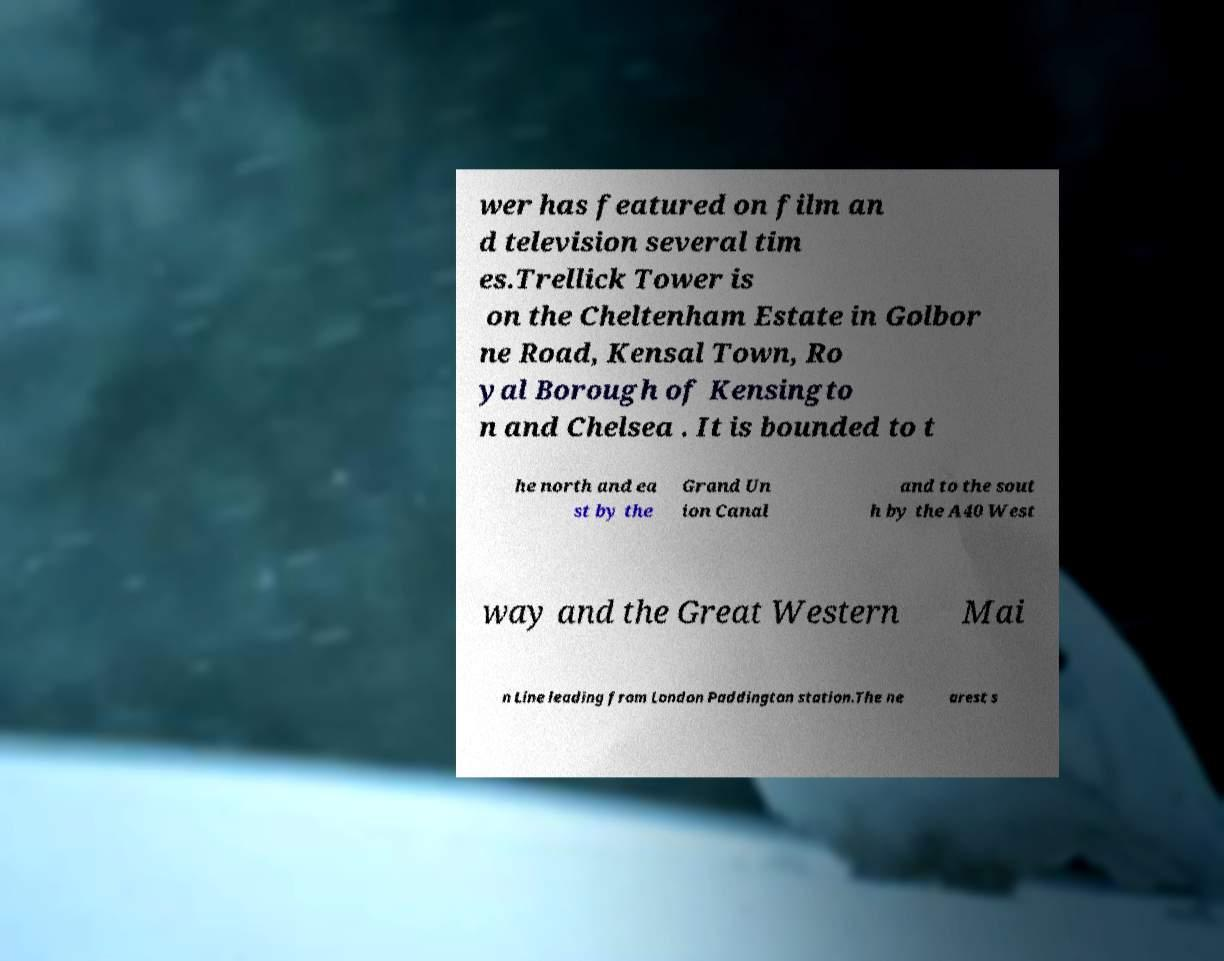Please identify and transcribe the text found in this image. wer has featured on film an d television several tim es.Trellick Tower is on the Cheltenham Estate in Golbor ne Road, Kensal Town, Ro yal Borough of Kensingto n and Chelsea . It is bounded to t he north and ea st by the Grand Un ion Canal and to the sout h by the A40 West way and the Great Western Mai n Line leading from London Paddington station.The ne arest s 